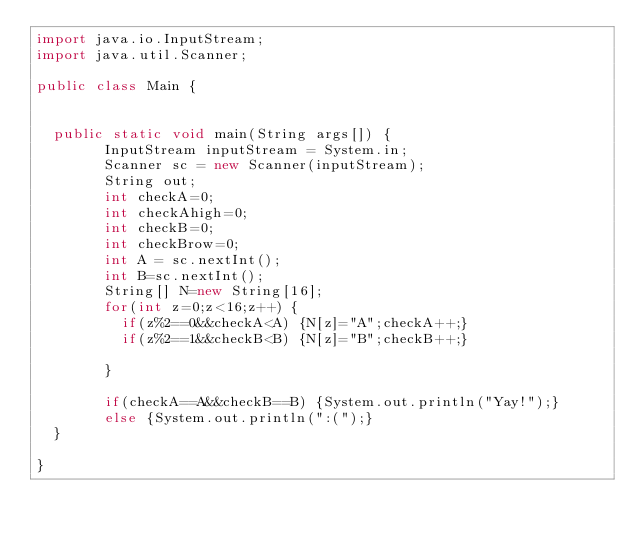Convert code to text. <code><loc_0><loc_0><loc_500><loc_500><_Java_>import java.io.InputStream;
import java.util.Scanner;

public class Main {


	public static void main(String args[]) {
        InputStream inputStream = System.in;
        Scanner sc = new Scanner(inputStream);
        String out;
        int checkA=0;
        int checkAhigh=0;
        int checkB=0;
        int checkBrow=0;
        int A = sc.nextInt();
        int B=sc.nextInt();
        String[] N=new String[16];
        for(int z=0;z<16;z++) {
        	if(z%2==0&&checkA<A) {N[z]="A";checkA++;}
        	if(z%2==1&&checkB<B) {N[z]="B";checkB++;}
        	
        }
        
        if(checkA==A&&checkB==B) {System.out.println("Yay!");}
        else {System.out.println(":(");}
	}

}
</code> 